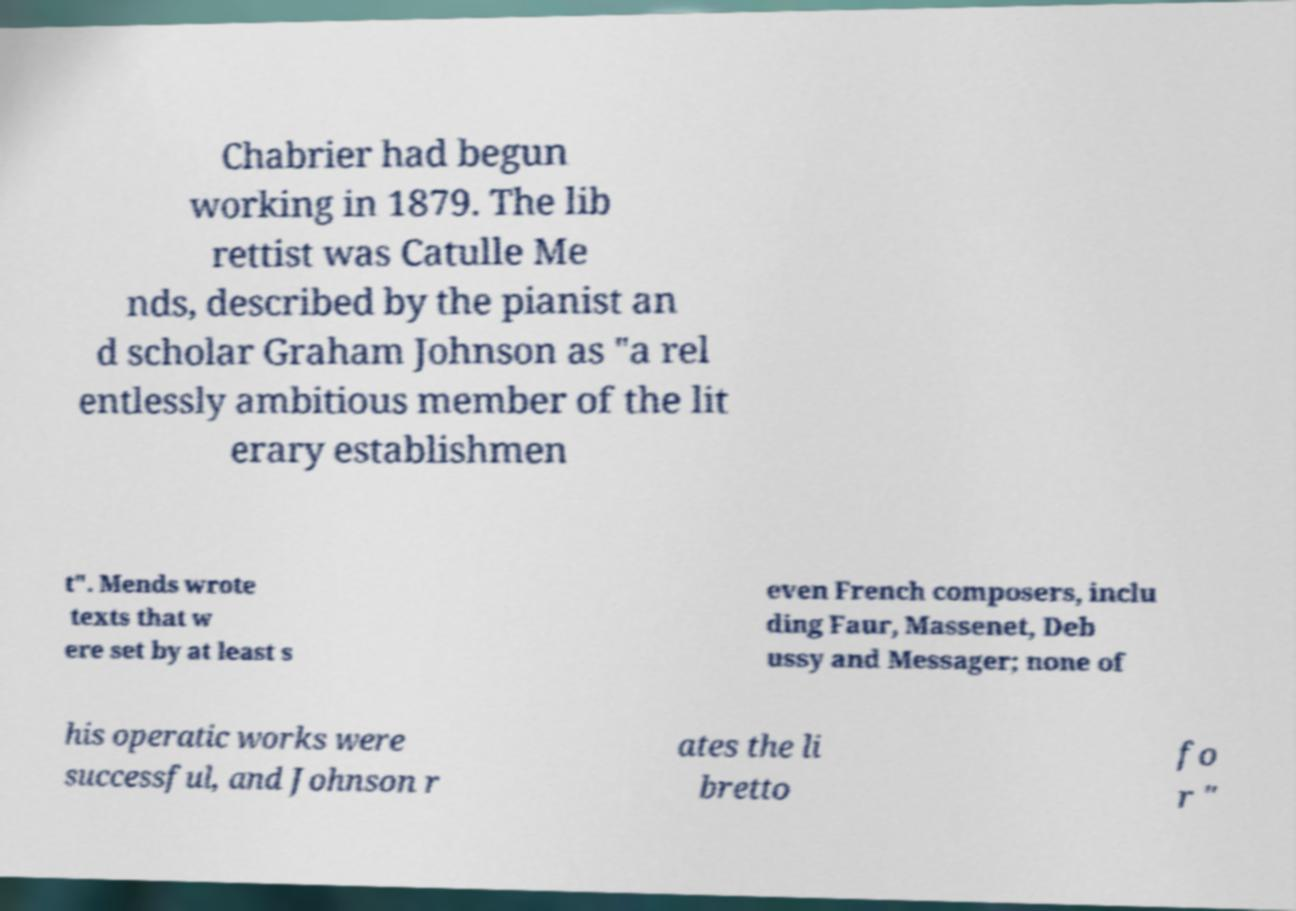There's text embedded in this image that I need extracted. Can you transcribe it verbatim? Chabrier had begun working in 1879. The lib rettist was Catulle Me nds, described by the pianist an d scholar Graham Johnson as "a rel entlessly ambitious member of the lit erary establishmen t". Mends wrote texts that w ere set by at least s even French composers, inclu ding Faur, Massenet, Deb ussy and Messager; none of his operatic works were successful, and Johnson r ates the li bretto fo r " 